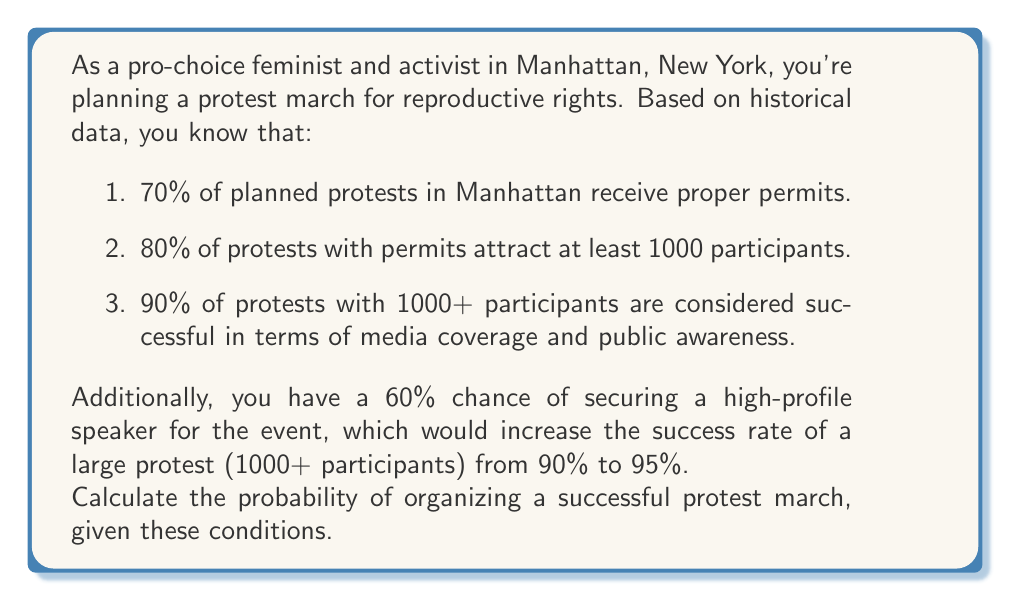What is the answer to this math problem? Let's break this down step-by-step using the law of total probability:

1) First, let's define our events:
   A: The protest receives proper permits
   B: The protest attracts at least 1000 participants
   C: The protest is successful
   D: A high-profile speaker is secured

2) We can calculate the probability of success as follows:

   $P(C) = P(C|A,B,D)P(A)P(B|A)P(D) + P(C|A,B,\text{not }D)P(A)P(B|A)P(\text{not }D)$
   $+ P(C|\text{not }A)P(\text{not }A)$

3) Let's plug in the values:
   $P(A) = 0.70$
   $P(B|A) = 0.80$
   $P(D) = 0.60$
   $P(C|A,B,D) = 0.95$
   $P(C|A,B,\text{not }D) = 0.90$
   $P(C|\text{not }A) = 0$ (assuming a protest without permits is never successful)

4) Now we can calculate:

   $P(C) = 0.95 * 0.70 * 0.80 * 0.60 + 0.90 * 0.70 * 0.80 * 0.40 + 0 * 0.30$

5) Simplifying:
   $P(C) = 0.3192 + 0.2016 + 0 = 0.5208$

Therefore, the probability of organizing a successful protest march is approximately 0.5208 or 52.08%.
Answer: The probability of organizing a successful protest march is approximately 0.5208 or 52.08%. 